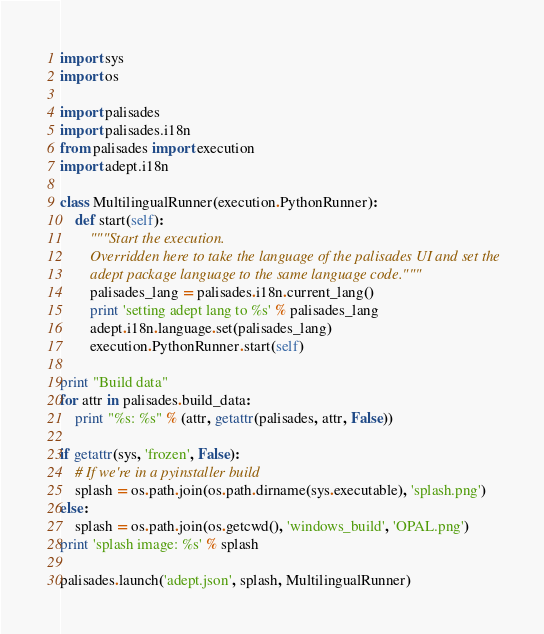<code> <loc_0><loc_0><loc_500><loc_500><_Python_>import sys
import os

import palisades
import palisades.i18n
from palisades import execution
import adept.i18n

class MultilingualRunner(execution.PythonRunner):
    def start(self):
        """Start the execution.
        Overridden here to take the language of the palisades UI and set the
        adept package language to the same language code."""
        palisades_lang = palisades.i18n.current_lang()
        print 'setting adept lang to %s' % palisades_lang
        adept.i18n.language.set(palisades_lang)
        execution.PythonRunner.start(self)

print "Build data"
for attr in palisades.build_data:
    print "%s: %s" % (attr, getattr(palisades, attr, False))

if getattr(sys, 'frozen', False):
    # If we're in a pyinstaller build
    splash = os.path.join(os.path.dirname(sys.executable), 'splash.png')
else:
    splash = os.path.join(os.getcwd(), 'windows_build', 'OPAL.png')
print 'splash image: %s' % splash

palisades.launch('adept.json', splash, MultilingualRunner)
</code> 